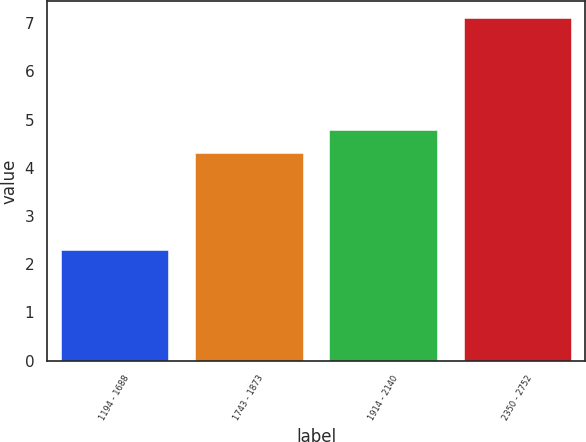Convert chart. <chart><loc_0><loc_0><loc_500><loc_500><bar_chart><fcel>1194 - 1688<fcel>1743 - 1873<fcel>1914 - 2140<fcel>2350 - 2752<nl><fcel>2.3<fcel>4.3<fcel>4.78<fcel>7.1<nl></chart> 